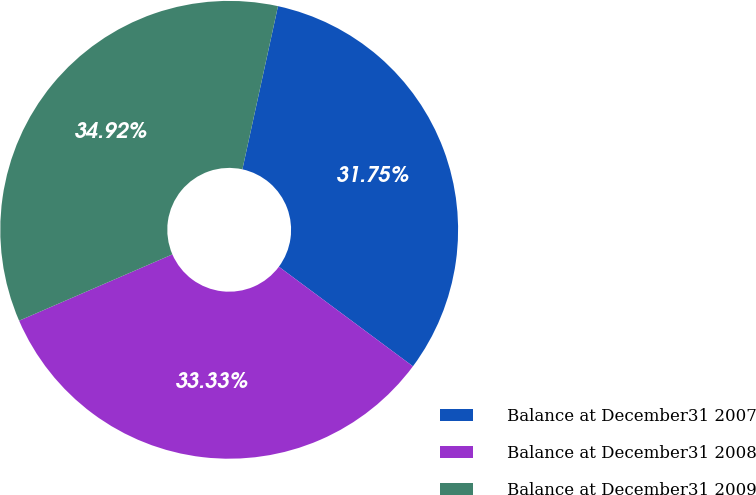Convert chart to OTSL. <chart><loc_0><loc_0><loc_500><loc_500><pie_chart><fcel>Balance at December31 2007<fcel>Balance at December31 2008<fcel>Balance at December31 2009<nl><fcel>31.75%<fcel>33.33%<fcel>34.92%<nl></chart> 